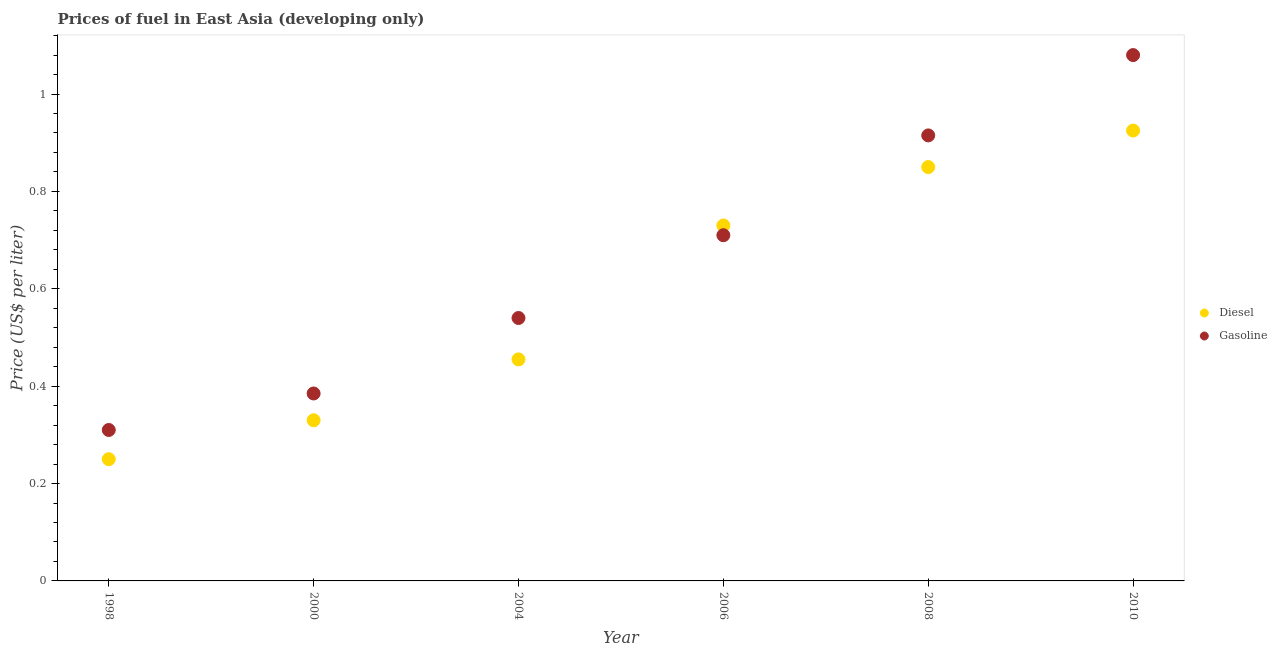How many different coloured dotlines are there?
Provide a succinct answer. 2. Is the number of dotlines equal to the number of legend labels?
Give a very brief answer. Yes. What is the gasoline price in 2000?
Provide a short and direct response. 0.39. Across all years, what is the maximum diesel price?
Make the answer very short. 0.93. Across all years, what is the minimum gasoline price?
Make the answer very short. 0.31. What is the total gasoline price in the graph?
Give a very brief answer. 3.94. What is the difference between the diesel price in 1998 and that in 2006?
Keep it short and to the point. -0.48. What is the difference between the gasoline price in 2000 and the diesel price in 2004?
Offer a very short reply. -0.07. What is the average gasoline price per year?
Your answer should be compact. 0.66. In the year 2006, what is the difference between the diesel price and gasoline price?
Ensure brevity in your answer.  0.02. What is the difference between the highest and the second highest diesel price?
Make the answer very short. 0.08. What is the difference between the highest and the lowest diesel price?
Ensure brevity in your answer.  0.68. Is the sum of the gasoline price in 2004 and 2010 greater than the maximum diesel price across all years?
Offer a very short reply. Yes. Does the gasoline price monotonically increase over the years?
Your answer should be very brief. Yes. Is the gasoline price strictly less than the diesel price over the years?
Keep it short and to the point. No. How many dotlines are there?
Your answer should be compact. 2. How many years are there in the graph?
Ensure brevity in your answer.  6. Are the values on the major ticks of Y-axis written in scientific E-notation?
Make the answer very short. No. Does the graph contain any zero values?
Your response must be concise. No. Does the graph contain grids?
Your response must be concise. No. How many legend labels are there?
Make the answer very short. 2. What is the title of the graph?
Make the answer very short. Prices of fuel in East Asia (developing only). What is the label or title of the Y-axis?
Make the answer very short. Price (US$ per liter). What is the Price (US$ per liter) in Gasoline in 1998?
Your answer should be compact. 0.31. What is the Price (US$ per liter) of Diesel in 2000?
Offer a terse response. 0.33. What is the Price (US$ per liter) in Gasoline in 2000?
Offer a terse response. 0.39. What is the Price (US$ per liter) of Diesel in 2004?
Your answer should be compact. 0.46. What is the Price (US$ per liter) in Gasoline in 2004?
Provide a short and direct response. 0.54. What is the Price (US$ per liter) in Diesel in 2006?
Offer a terse response. 0.73. What is the Price (US$ per liter) in Gasoline in 2006?
Offer a terse response. 0.71. What is the Price (US$ per liter) in Diesel in 2008?
Ensure brevity in your answer.  0.85. What is the Price (US$ per liter) of Gasoline in 2008?
Give a very brief answer. 0.92. What is the Price (US$ per liter) in Diesel in 2010?
Keep it short and to the point. 0.93. What is the Price (US$ per liter) in Gasoline in 2010?
Provide a short and direct response. 1.08. Across all years, what is the maximum Price (US$ per liter) of Diesel?
Give a very brief answer. 0.93. Across all years, what is the maximum Price (US$ per liter) in Gasoline?
Your answer should be very brief. 1.08. Across all years, what is the minimum Price (US$ per liter) in Gasoline?
Offer a very short reply. 0.31. What is the total Price (US$ per liter) of Diesel in the graph?
Offer a very short reply. 3.54. What is the total Price (US$ per liter) in Gasoline in the graph?
Provide a succinct answer. 3.94. What is the difference between the Price (US$ per liter) of Diesel in 1998 and that in 2000?
Ensure brevity in your answer.  -0.08. What is the difference between the Price (US$ per liter) of Gasoline in 1998 and that in 2000?
Your answer should be very brief. -0.07. What is the difference between the Price (US$ per liter) in Diesel in 1998 and that in 2004?
Provide a succinct answer. -0.2. What is the difference between the Price (US$ per liter) of Gasoline in 1998 and that in 2004?
Give a very brief answer. -0.23. What is the difference between the Price (US$ per liter) in Diesel in 1998 and that in 2006?
Offer a very short reply. -0.48. What is the difference between the Price (US$ per liter) of Gasoline in 1998 and that in 2006?
Provide a succinct answer. -0.4. What is the difference between the Price (US$ per liter) in Diesel in 1998 and that in 2008?
Provide a succinct answer. -0.6. What is the difference between the Price (US$ per liter) in Gasoline in 1998 and that in 2008?
Make the answer very short. -0.6. What is the difference between the Price (US$ per liter) in Diesel in 1998 and that in 2010?
Keep it short and to the point. -0.68. What is the difference between the Price (US$ per liter) in Gasoline in 1998 and that in 2010?
Offer a very short reply. -0.77. What is the difference between the Price (US$ per liter) of Diesel in 2000 and that in 2004?
Your answer should be compact. -0.12. What is the difference between the Price (US$ per liter) of Gasoline in 2000 and that in 2004?
Provide a short and direct response. -0.15. What is the difference between the Price (US$ per liter) in Gasoline in 2000 and that in 2006?
Your answer should be very brief. -0.33. What is the difference between the Price (US$ per liter) of Diesel in 2000 and that in 2008?
Keep it short and to the point. -0.52. What is the difference between the Price (US$ per liter) in Gasoline in 2000 and that in 2008?
Make the answer very short. -0.53. What is the difference between the Price (US$ per liter) in Diesel in 2000 and that in 2010?
Provide a short and direct response. -0.59. What is the difference between the Price (US$ per liter) in Gasoline in 2000 and that in 2010?
Your answer should be very brief. -0.69. What is the difference between the Price (US$ per liter) of Diesel in 2004 and that in 2006?
Ensure brevity in your answer.  -0.28. What is the difference between the Price (US$ per liter) of Gasoline in 2004 and that in 2006?
Provide a succinct answer. -0.17. What is the difference between the Price (US$ per liter) of Diesel in 2004 and that in 2008?
Offer a very short reply. -0.4. What is the difference between the Price (US$ per liter) of Gasoline in 2004 and that in 2008?
Your answer should be compact. -0.38. What is the difference between the Price (US$ per liter) of Diesel in 2004 and that in 2010?
Provide a short and direct response. -0.47. What is the difference between the Price (US$ per liter) in Gasoline in 2004 and that in 2010?
Your response must be concise. -0.54. What is the difference between the Price (US$ per liter) in Diesel in 2006 and that in 2008?
Offer a very short reply. -0.12. What is the difference between the Price (US$ per liter) of Gasoline in 2006 and that in 2008?
Offer a terse response. -0.2. What is the difference between the Price (US$ per liter) in Diesel in 2006 and that in 2010?
Offer a terse response. -0.2. What is the difference between the Price (US$ per liter) in Gasoline in 2006 and that in 2010?
Ensure brevity in your answer.  -0.37. What is the difference between the Price (US$ per liter) in Diesel in 2008 and that in 2010?
Your answer should be compact. -0.07. What is the difference between the Price (US$ per liter) in Gasoline in 2008 and that in 2010?
Offer a terse response. -0.17. What is the difference between the Price (US$ per liter) in Diesel in 1998 and the Price (US$ per liter) in Gasoline in 2000?
Offer a very short reply. -0.14. What is the difference between the Price (US$ per liter) of Diesel in 1998 and the Price (US$ per liter) of Gasoline in 2004?
Make the answer very short. -0.29. What is the difference between the Price (US$ per liter) in Diesel in 1998 and the Price (US$ per liter) in Gasoline in 2006?
Offer a terse response. -0.46. What is the difference between the Price (US$ per liter) of Diesel in 1998 and the Price (US$ per liter) of Gasoline in 2008?
Offer a terse response. -0.67. What is the difference between the Price (US$ per liter) of Diesel in 1998 and the Price (US$ per liter) of Gasoline in 2010?
Your response must be concise. -0.83. What is the difference between the Price (US$ per liter) in Diesel in 2000 and the Price (US$ per liter) in Gasoline in 2004?
Your response must be concise. -0.21. What is the difference between the Price (US$ per liter) in Diesel in 2000 and the Price (US$ per liter) in Gasoline in 2006?
Your response must be concise. -0.38. What is the difference between the Price (US$ per liter) in Diesel in 2000 and the Price (US$ per liter) in Gasoline in 2008?
Ensure brevity in your answer.  -0.58. What is the difference between the Price (US$ per liter) in Diesel in 2000 and the Price (US$ per liter) in Gasoline in 2010?
Your answer should be compact. -0.75. What is the difference between the Price (US$ per liter) in Diesel in 2004 and the Price (US$ per liter) in Gasoline in 2006?
Your answer should be very brief. -0.26. What is the difference between the Price (US$ per liter) in Diesel in 2004 and the Price (US$ per liter) in Gasoline in 2008?
Your answer should be very brief. -0.46. What is the difference between the Price (US$ per liter) of Diesel in 2004 and the Price (US$ per liter) of Gasoline in 2010?
Provide a short and direct response. -0.62. What is the difference between the Price (US$ per liter) of Diesel in 2006 and the Price (US$ per liter) of Gasoline in 2008?
Give a very brief answer. -0.18. What is the difference between the Price (US$ per liter) of Diesel in 2006 and the Price (US$ per liter) of Gasoline in 2010?
Keep it short and to the point. -0.35. What is the difference between the Price (US$ per liter) of Diesel in 2008 and the Price (US$ per liter) of Gasoline in 2010?
Keep it short and to the point. -0.23. What is the average Price (US$ per liter) in Diesel per year?
Give a very brief answer. 0.59. What is the average Price (US$ per liter) of Gasoline per year?
Your answer should be compact. 0.66. In the year 1998, what is the difference between the Price (US$ per liter) in Diesel and Price (US$ per liter) in Gasoline?
Your response must be concise. -0.06. In the year 2000, what is the difference between the Price (US$ per liter) of Diesel and Price (US$ per liter) of Gasoline?
Your answer should be compact. -0.06. In the year 2004, what is the difference between the Price (US$ per liter) in Diesel and Price (US$ per liter) in Gasoline?
Offer a terse response. -0.09. In the year 2006, what is the difference between the Price (US$ per liter) in Diesel and Price (US$ per liter) in Gasoline?
Offer a very short reply. 0.02. In the year 2008, what is the difference between the Price (US$ per liter) in Diesel and Price (US$ per liter) in Gasoline?
Ensure brevity in your answer.  -0.07. In the year 2010, what is the difference between the Price (US$ per liter) in Diesel and Price (US$ per liter) in Gasoline?
Keep it short and to the point. -0.15. What is the ratio of the Price (US$ per liter) of Diesel in 1998 to that in 2000?
Offer a very short reply. 0.76. What is the ratio of the Price (US$ per liter) of Gasoline in 1998 to that in 2000?
Provide a succinct answer. 0.81. What is the ratio of the Price (US$ per liter) in Diesel in 1998 to that in 2004?
Offer a terse response. 0.55. What is the ratio of the Price (US$ per liter) in Gasoline in 1998 to that in 2004?
Your answer should be very brief. 0.57. What is the ratio of the Price (US$ per liter) of Diesel in 1998 to that in 2006?
Ensure brevity in your answer.  0.34. What is the ratio of the Price (US$ per liter) of Gasoline in 1998 to that in 2006?
Provide a short and direct response. 0.44. What is the ratio of the Price (US$ per liter) in Diesel in 1998 to that in 2008?
Offer a terse response. 0.29. What is the ratio of the Price (US$ per liter) in Gasoline in 1998 to that in 2008?
Provide a short and direct response. 0.34. What is the ratio of the Price (US$ per liter) of Diesel in 1998 to that in 2010?
Your answer should be compact. 0.27. What is the ratio of the Price (US$ per liter) in Gasoline in 1998 to that in 2010?
Give a very brief answer. 0.29. What is the ratio of the Price (US$ per liter) of Diesel in 2000 to that in 2004?
Give a very brief answer. 0.73. What is the ratio of the Price (US$ per liter) of Gasoline in 2000 to that in 2004?
Your response must be concise. 0.71. What is the ratio of the Price (US$ per liter) in Diesel in 2000 to that in 2006?
Provide a succinct answer. 0.45. What is the ratio of the Price (US$ per liter) of Gasoline in 2000 to that in 2006?
Your answer should be compact. 0.54. What is the ratio of the Price (US$ per liter) of Diesel in 2000 to that in 2008?
Offer a terse response. 0.39. What is the ratio of the Price (US$ per liter) of Gasoline in 2000 to that in 2008?
Give a very brief answer. 0.42. What is the ratio of the Price (US$ per liter) of Diesel in 2000 to that in 2010?
Offer a very short reply. 0.36. What is the ratio of the Price (US$ per liter) of Gasoline in 2000 to that in 2010?
Your answer should be very brief. 0.36. What is the ratio of the Price (US$ per liter) in Diesel in 2004 to that in 2006?
Offer a very short reply. 0.62. What is the ratio of the Price (US$ per liter) in Gasoline in 2004 to that in 2006?
Provide a succinct answer. 0.76. What is the ratio of the Price (US$ per liter) of Diesel in 2004 to that in 2008?
Provide a succinct answer. 0.54. What is the ratio of the Price (US$ per liter) in Gasoline in 2004 to that in 2008?
Offer a very short reply. 0.59. What is the ratio of the Price (US$ per liter) of Diesel in 2004 to that in 2010?
Your response must be concise. 0.49. What is the ratio of the Price (US$ per liter) of Gasoline in 2004 to that in 2010?
Give a very brief answer. 0.5. What is the ratio of the Price (US$ per liter) in Diesel in 2006 to that in 2008?
Your answer should be very brief. 0.86. What is the ratio of the Price (US$ per liter) of Gasoline in 2006 to that in 2008?
Make the answer very short. 0.78. What is the ratio of the Price (US$ per liter) in Diesel in 2006 to that in 2010?
Your response must be concise. 0.79. What is the ratio of the Price (US$ per liter) of Gasoline in 2006 to that in 2010?
Your answer should be compact. 0.66. What is the ratio of the Price (US$ per liter) in Diesel in 2008 to that in 2010?
Offer a terse response. 0.92. What is the ratio of the Price (US$ per liter) in Gasoline in 2008 to that in 2010?
Your answer should be very brief. 0.85. What is the difference between the highest and the second highest Price (US$ per liter) in Diesel?
Offer a very short reply. 0.07. What is the difference between the highest and the second highest Price (US$ per liter) in Gasoline?
Make the answer very short. 0.17. What is the difference between the highest and the lowest Price (US$ per liter) in Diesel?
Provide a succinct answer. 0.68. What is the difference between the highest and the lowest Price (US$ per liter) of Gasoline?
Provide a succinct answer. 0.77. 